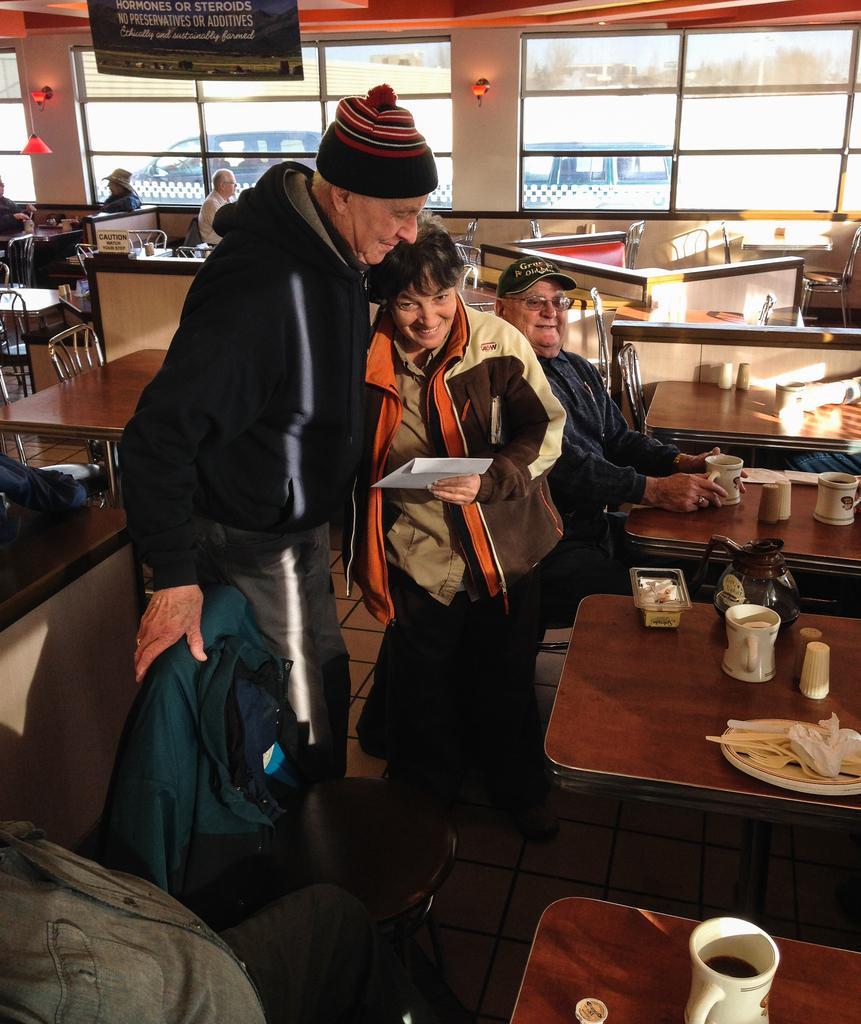How would you summarize this image in a sentence or two? There are two persons standing in front of a table which has some objects on it and there is another person sitting behind them, In background there are cars. 